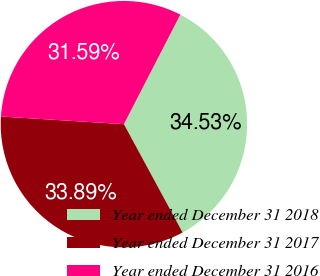Convert chart to OTSL. <chart><loc_0><loc_0><loc_500><loc_500><pie_chart><fcel>Year ended December 31 2018<fcel>Year ended December 31 2017<fcel>Year ended December 31 2016<nl><fcel>34.53%<fcel>33.89%<fcel>31.59%<nl></chart> 